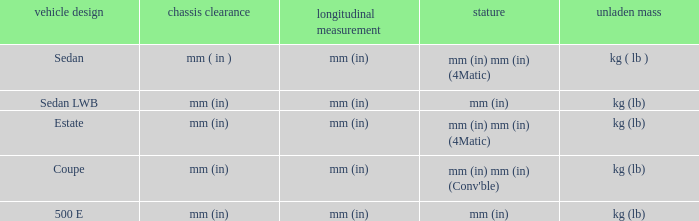Could you help me parse every detail presented in this table? {'header': ['vehicle design', 'chassis clearance', 'longitudinal measurement', 'stature', 'unladen mass'], 'rows': [['Sedan', 'mm ( in )', 'mm (in)', 'mm (in) mm (in) (4Matic)', 'kg ( lb )'], ['Sedan LWB', 'mm (in)', 'mm (in)', 'mm (in)', 'kg (lb)'], ['Estate', 'mm (in)', 'mm (in)', 'mm (in) mm (in) (4Matic)', 'kg (lb)'], ['Coupe', 'mm (in)', 'mm (in)', "mm (in) mm (in) (Conv'ble)", 'kg (lb)'], ['500 E', 'mm (in)', 'mm (in)', 'mm (in)', 'kg (lb)']]} What's the length of the model with Sedan body style? Mm (in). 